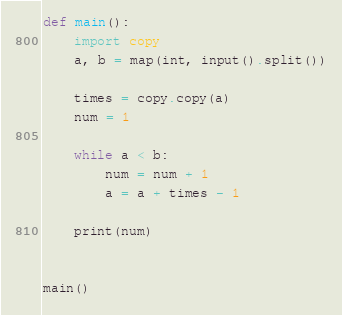Convert code to text. <code><loc_0><loc_0><loc_500><loc_500><_Python_>def main():
    import copy
    a, b = map(int, input().split())
    
    times = copy.copy(a)
    num = 1

    while a < b:
        num = num + 1
        a = a + times - 1

    print(num)
    

main()</code> 